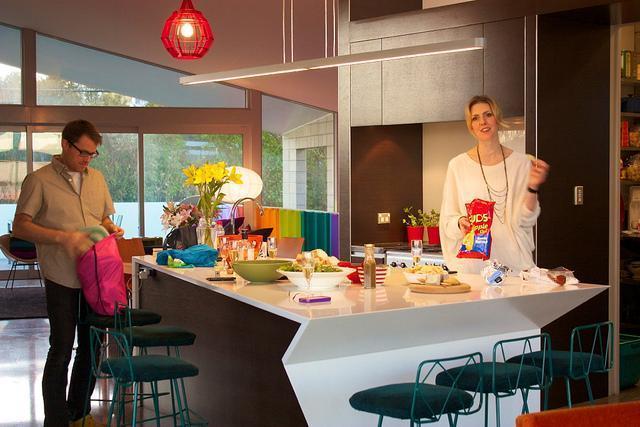How many different flowers are on the table?
Give a very brief answer. 2. How many chairs can be seen?
Give a very brief answer. 4. How many people are visible?
Give a very brief answer. 2. How many motorcycles are between the sidewalk and the yellow line in the road?
Give a very brief answer. 0. 